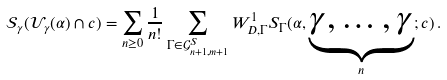Convert formula to latex. <formula><loc_0><loc_0><loc_500><loc_500>\mathcal { S } _ { \gamma } ( \mathcal { U } _ { \gamma } ( \alpha ) \cap c ) = \sum _ { n \geq 0 } \frac { 1 } { n ! } \sum _ { \Gamma \in \mathcal { G } ^ { S } _ { n + 1 , m + 1 } } W _ { D , \Gamma } ^ { 1 } S _ { \Gamma } ( \alpha , \underset { n } { \underbrace { \gamma , \dots , \gamma } } ; c ) \, .</formula> 